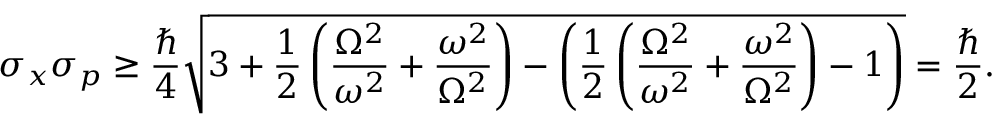<formula> <loc_0><loc_0><loc_500><loc_500>\sigma _ { x } \sigma _ { p } \geq { \frac { } { 4 } } { \sqrt { 3 + { \frac { 1 } { 2 } } \left ( { \frac { \Omega ^ { 2 } } { \omega ^ { 2 } } } + { \frac { \omega ^ { 2 } } { \Omega ^ { 2 } } } \right ) - \left ( { \frac { 1 } { 2 } } \left ( { \frac { \Omega ^ { 2 } } { \omega ^ { 2 } } } + { \frac { \omega ^ { 2 } } { \Omega ^ { 2 } } } \right ) - 1 \right ) } } = { \frac { } { 2 } } .</formula> 